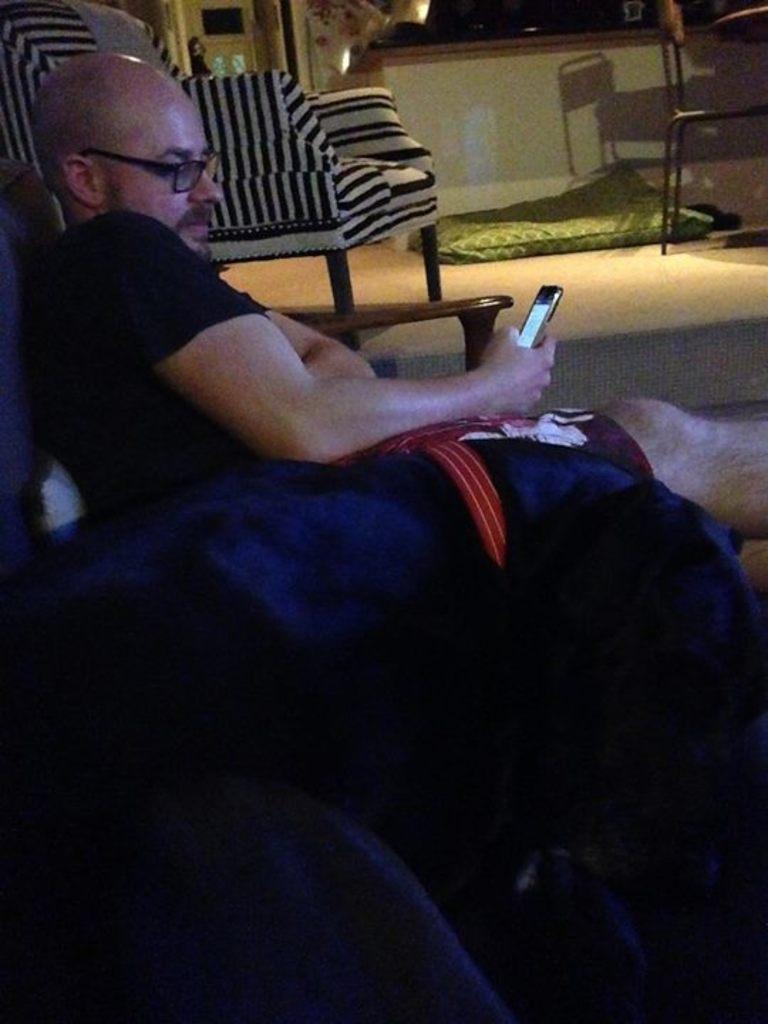Can you describe this image briefly? In this image, we can see a person wearing spectacles is holding a mobile phone and sitting. We can also see a pet. We can see the ground with an object. We can see some chairs. We can see the desk and the wall. We can also see an object at the top. 